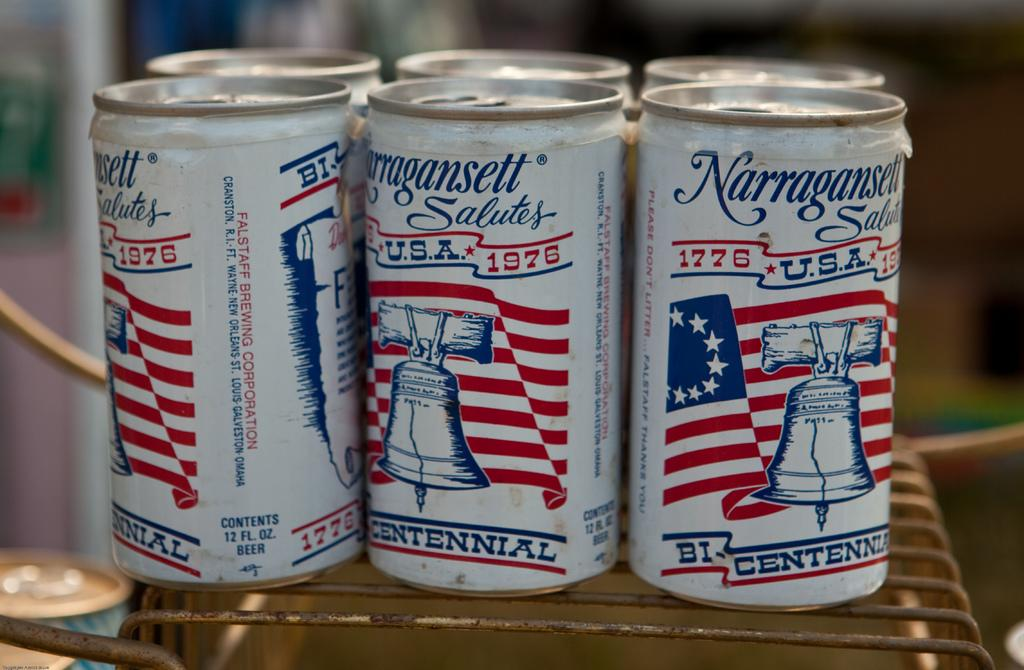Provide a one-sentence caption for the provided image. A six pack of Narragansett has a red, white and blue bi-centennial theme. 